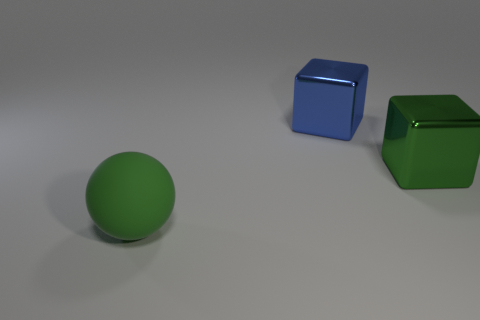Do the green ball and the green object that is to the right of the large green rubber object have the same size?
Give a very brief answer. Yes. What color is the big block in front of the block that is left of the green thing behind the ball?
Offer a terse response. Green. What color is the rubber thing?
Make the answer very short. Green. Is the number of large blue blocks on the right side of the large green rubber sphere greater than the number of large green cubes that are to the right of the big green metal thing?
Ensure brevity in your answer.  Yes. Is the shape of the blue thing the same as the big green object behind the matte ball?
Ensure brevity in your answer.  Yes. Does the green thing that is on the right side of the large green sphere have the same size as the metal block behind the green block?
Offer a very short reply. Yes. There is a green thing left of the big green object behind the matte object; is there a big ball to the right of it?
Your answer should be very brief. No. Are there fewer large green shiny objects that are left of the green matte object than large objects right of the big blue metal thing?
Keep it short and to the point. Yes. What shape is the large blue thing that is made of the same material as the green cube?
Offer a very short reply. Cube. Is the number of small blue shiny cylinders greater than the number of metallic objects?
Give a very brief answer. No. 